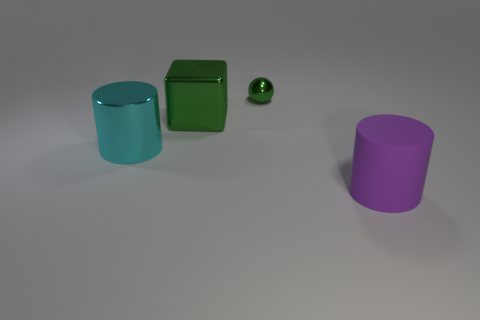Subtract all purple cubes. Subtract all blue cylinders. How many cubes are left? 1 Add 3 large purple rubber cylinders. How many objects exist? 7 Subtract all blocks. How many objects are left? 3 Add 2 green spheres. How many green spheres exist? 3 Subtract 0 brown cylinders. How many objects are left? 4 Subtract all green cubes. Subtract all big cylinders. How many objects are left? 1 Add 4 cyan metallic cylinders. How many cyan metallic cylinders are left? 5 